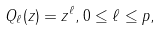<formula> <loc_0><loc_0><loc_500><loc_500>Q _ { \ell } ( z ) = z ^ { \ell } , 0 \leq \ell \leq p ,</formula> 